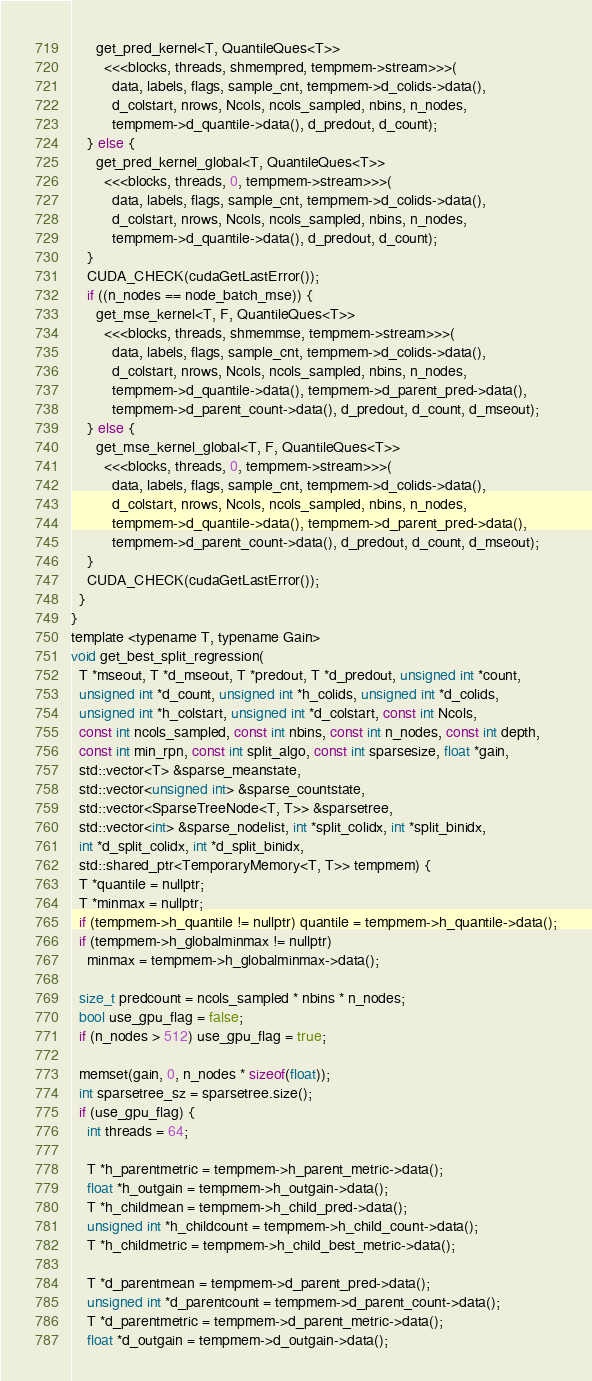Convert code to text. <code><loc_0><loc_0><loc_500><loc_500><_Cuda_>      get_pred_kernel<T, QuantileQues<T>>
        <<<blocks, threads, shmempred, tempmem->stream>>>(
          data, labels, flags, sample_cnt, tempmem->d_colids->data(),
          d_colstart, nrows, Ncols, ncols_sampled, nbins, n_nodes,
          tempmem->d_quantile->data(), d_predout, d_count);
    } else {
      get_pred_kernel_global<T, QuantileQues<T>>
        <<<blocks, threads, 0, tempmem->stream>>>(
          data, labels, flags, sample_cnt, tempmem->d_colids->data(),
          d_colstart, nrows, Ncols, ncols_sampled, nbins, n_nodes,
          tempmem->d_quantile->data(), d_predout, d_count);
    }
    CUDA_CHECK(cudaGetLastError());
    if ((n_nodes == node_batch_mse)) {
      get_mse_kernel<T, F, QuantileQues<T>>
        <<<blocks, threads, shmemmse, tempmem->stream>>>(
          data, labels, flags, sample_cnt, tempmem->d_colids->data(),
          d_colstart, nrows, Ncols, ncols_sampled, nbins, n_nodes,
          tempmem->d_quantile->data(), tempmem->d_parent_pred->data(),
          tempmem->d_parent_count->data(), d_predout, d_count, d_mseout);
    } else {
      get_mse_kernel_global<T, F, QuantileQues<T>>
        <<<blocks, threads, 0, tempmem->stream>>>(
          data, labels, flags, sample_cnt, tempmem->d_colids->data(),
          d_colstart, nrows, Ncols, ncols_sampled, nbins, n_nodes,
          tempmem->d_quantile->data(), tempmem->d_parent_pred->data(),
          tempmem->d_parent_count->data(), d_predout, d_count, d_mseout);
    }
    CUDA_CHECK(cudaGetLastError());
  }
}
template <typename T, typename Gain>
void get_best_split_regression(
  T *mseout, T *d_mseout, T *predout, T *d_predout, unsigned int *count,
  unsigned int *d_count, unsigned int *h_colids, unsigned int *d_colids,
  unsigned int *h_colstart, unsigned int *d_colstart, const int Ncols,
  const int ncols_sampled, const int nbins, const int n_nodes, const int depth,
  const int min_rpn, const int split_algo, const int sparsesize, float *gain,
  std::vector<T> &sparse_meanstate,
  std::vector<unsigned int> &sparse_countstate,
  std::vector<SparseTreeNode<T, T>> &sparsetree,
  std::vector<int> &sparse_nodelist, int *split_colidx, int *split_binidx,
  int *d_split_colidx, int *d_split_binidx,
  std::shared_ptr<TemporaryMemory<T, T>> tempmem) {
  T *quantile = nullptr;
  T *minmax = nullptr;
  if (tempmem->h_quantile != nullptr) quantile = tempmem->h_quantile->data();
  if (tempmem->h_globalminmax != nullptr)
    minmax = tempmem->h_globalminmax->data();

  size_t predcount = ncols_sampled * nbins * n_nodes;
  bool use_gpu_flag = false;
  if (n_nodes > 512) use_gpu_flag = true;

  memset(gain, 0, n_nodes * sizeof(float));
  int sparsetree_sz = sparsetree.size();
  if (use_gpu_flag) {
    int threads = 64;

    T *h_parentmetric = tempmem->h_parent_metric->data();
    float *h_outgain = tempmem->h_outgain->data();
    T *h_childmean = tempmem->h_child_pred->data();
    unsigned int *h_childcount = tempmem->h_child_count->data();
    T *h_childmetric = tempmem->h_child_best_metric->data();

    T *d_parentmean = tempmem->d_parent_pred->data();
    unsigned int *d_parentcount = tempmem->d_parent_count->data();
    T *d_parentmetric = tempmem->d_parent_metric->data();
    float *d_outgain = tempmem->d_outgain->data();</code> 